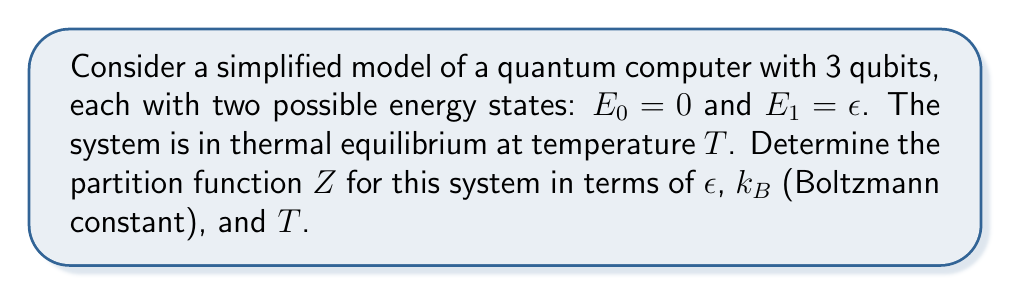Help me with this question. Let's approach this step-by-step:

1) The partition function $Z$ is defined as:
   $$Z = \sum_i e^{-E_i/k_BT}$$
   where $E_i$ are the possible energy states of the system.

2) In our system, each qubit has two possible states: $E_0 = 0$ and $E_1 = \epsilon$.

3) For a single qubit, the partition function would be:
   $$Z_1 = e^{-E_0/k_BT} + e^{-E_1/k_BT} = 1 + e^{-\epsilon/k_BT}$$

4) Since we have 3 independent qubits, and each configuration of the system is a combination of the states of these qubits, the total partition function is the product of the individual partition functions:

   $$Z = Z_1 \times Z_1 \times Z_1 = (1 + e^{-\epsilon/k_BT})^3$$

5) This can be expanded as:
   $$Z = 1 + 3e^{-\epsilon/k_BT} + 3e^{-2\epsilon/k_BT} + e^{-3\epsilon/k_BT}$$

This expression represents all possible configurations: 
- 1 state with all qubits in $E_0$ (coefficient 1)
- 3 states with one qubit in $E_1$ and two in $E_0$ (coefficient 3)
- 3 states with two qubits in $E_1$ and one in $E_0$ (coefficient 3)
- 1 state with all qubits in $E_1$ (coefficient 1)
Answer: $Z = (1 + e^{-\epsilon/k_BT})^3$ 